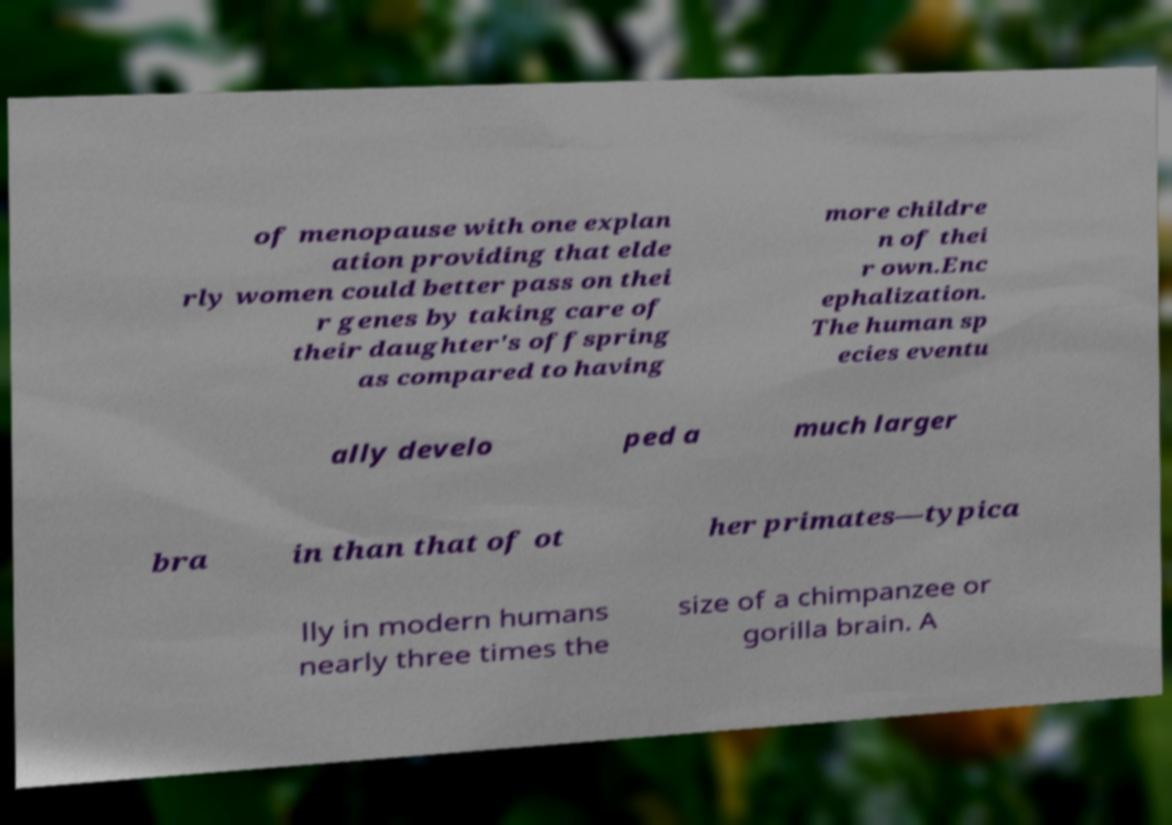Please read and relay the text visible in this image. What does it say? of menopause with one explan ation providing that elde rly women could better pass on thei r genes by taking care of their daughter's offspring as compared to having more childre n of thei r own.Enc ephalization. The human sp ecies eventu ally develo ped a much larger bra in than that of ot her primates—typica lly in modern humans nearly three times the size of a chimpanzee or gorilla brain. A 